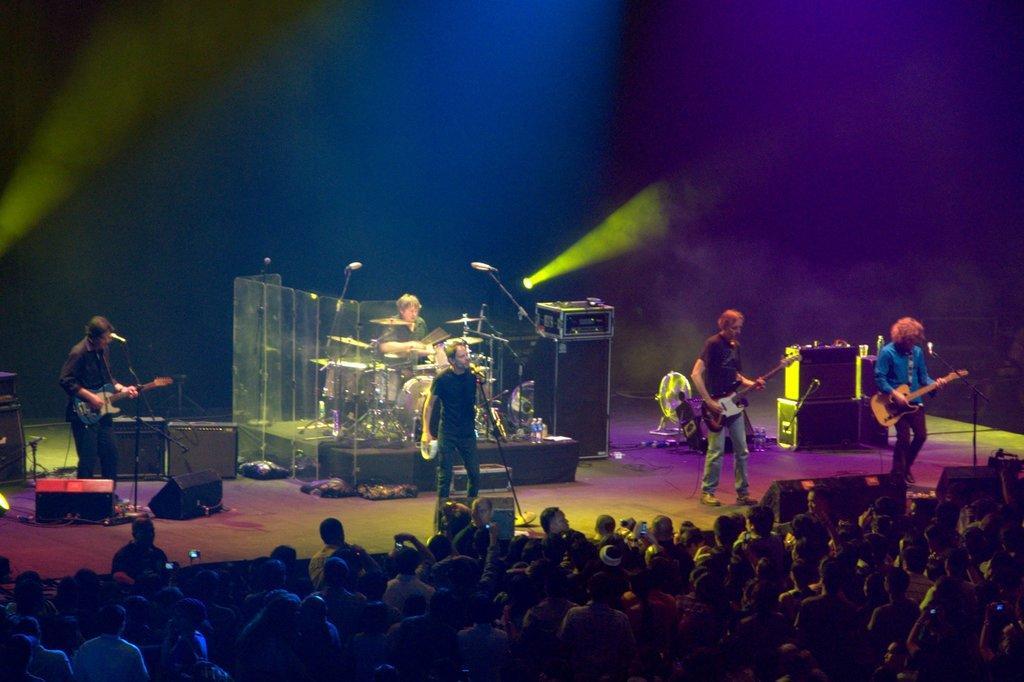Describe this image in one or two sentences. In this picture I can see few audience and few people on the dais and few of them playing guitars and a man standing and singing with the help of a microphone and another man playing drums on the back and I can see lighting. 